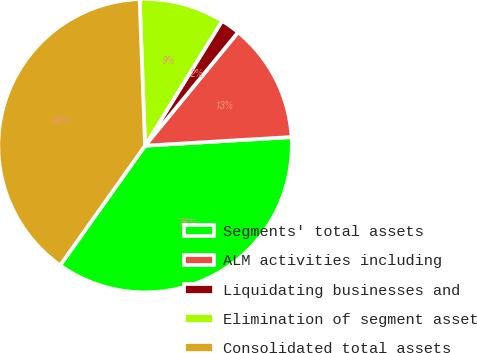Convert chart. <chart><loc_0><loc_0><loc_500><loc_500><pie_chart><fcel>Segments' total assets<fcel>ALM activities including<fcel>Liquidating businesses and<fcel>Elimination of segment asset<fcel>Consolidated total assets<nl><fcel>35.76%<fcel>13.13%<fcel>2.13%<fcel>9.39%<fcel>39.59%<nl></chart> 